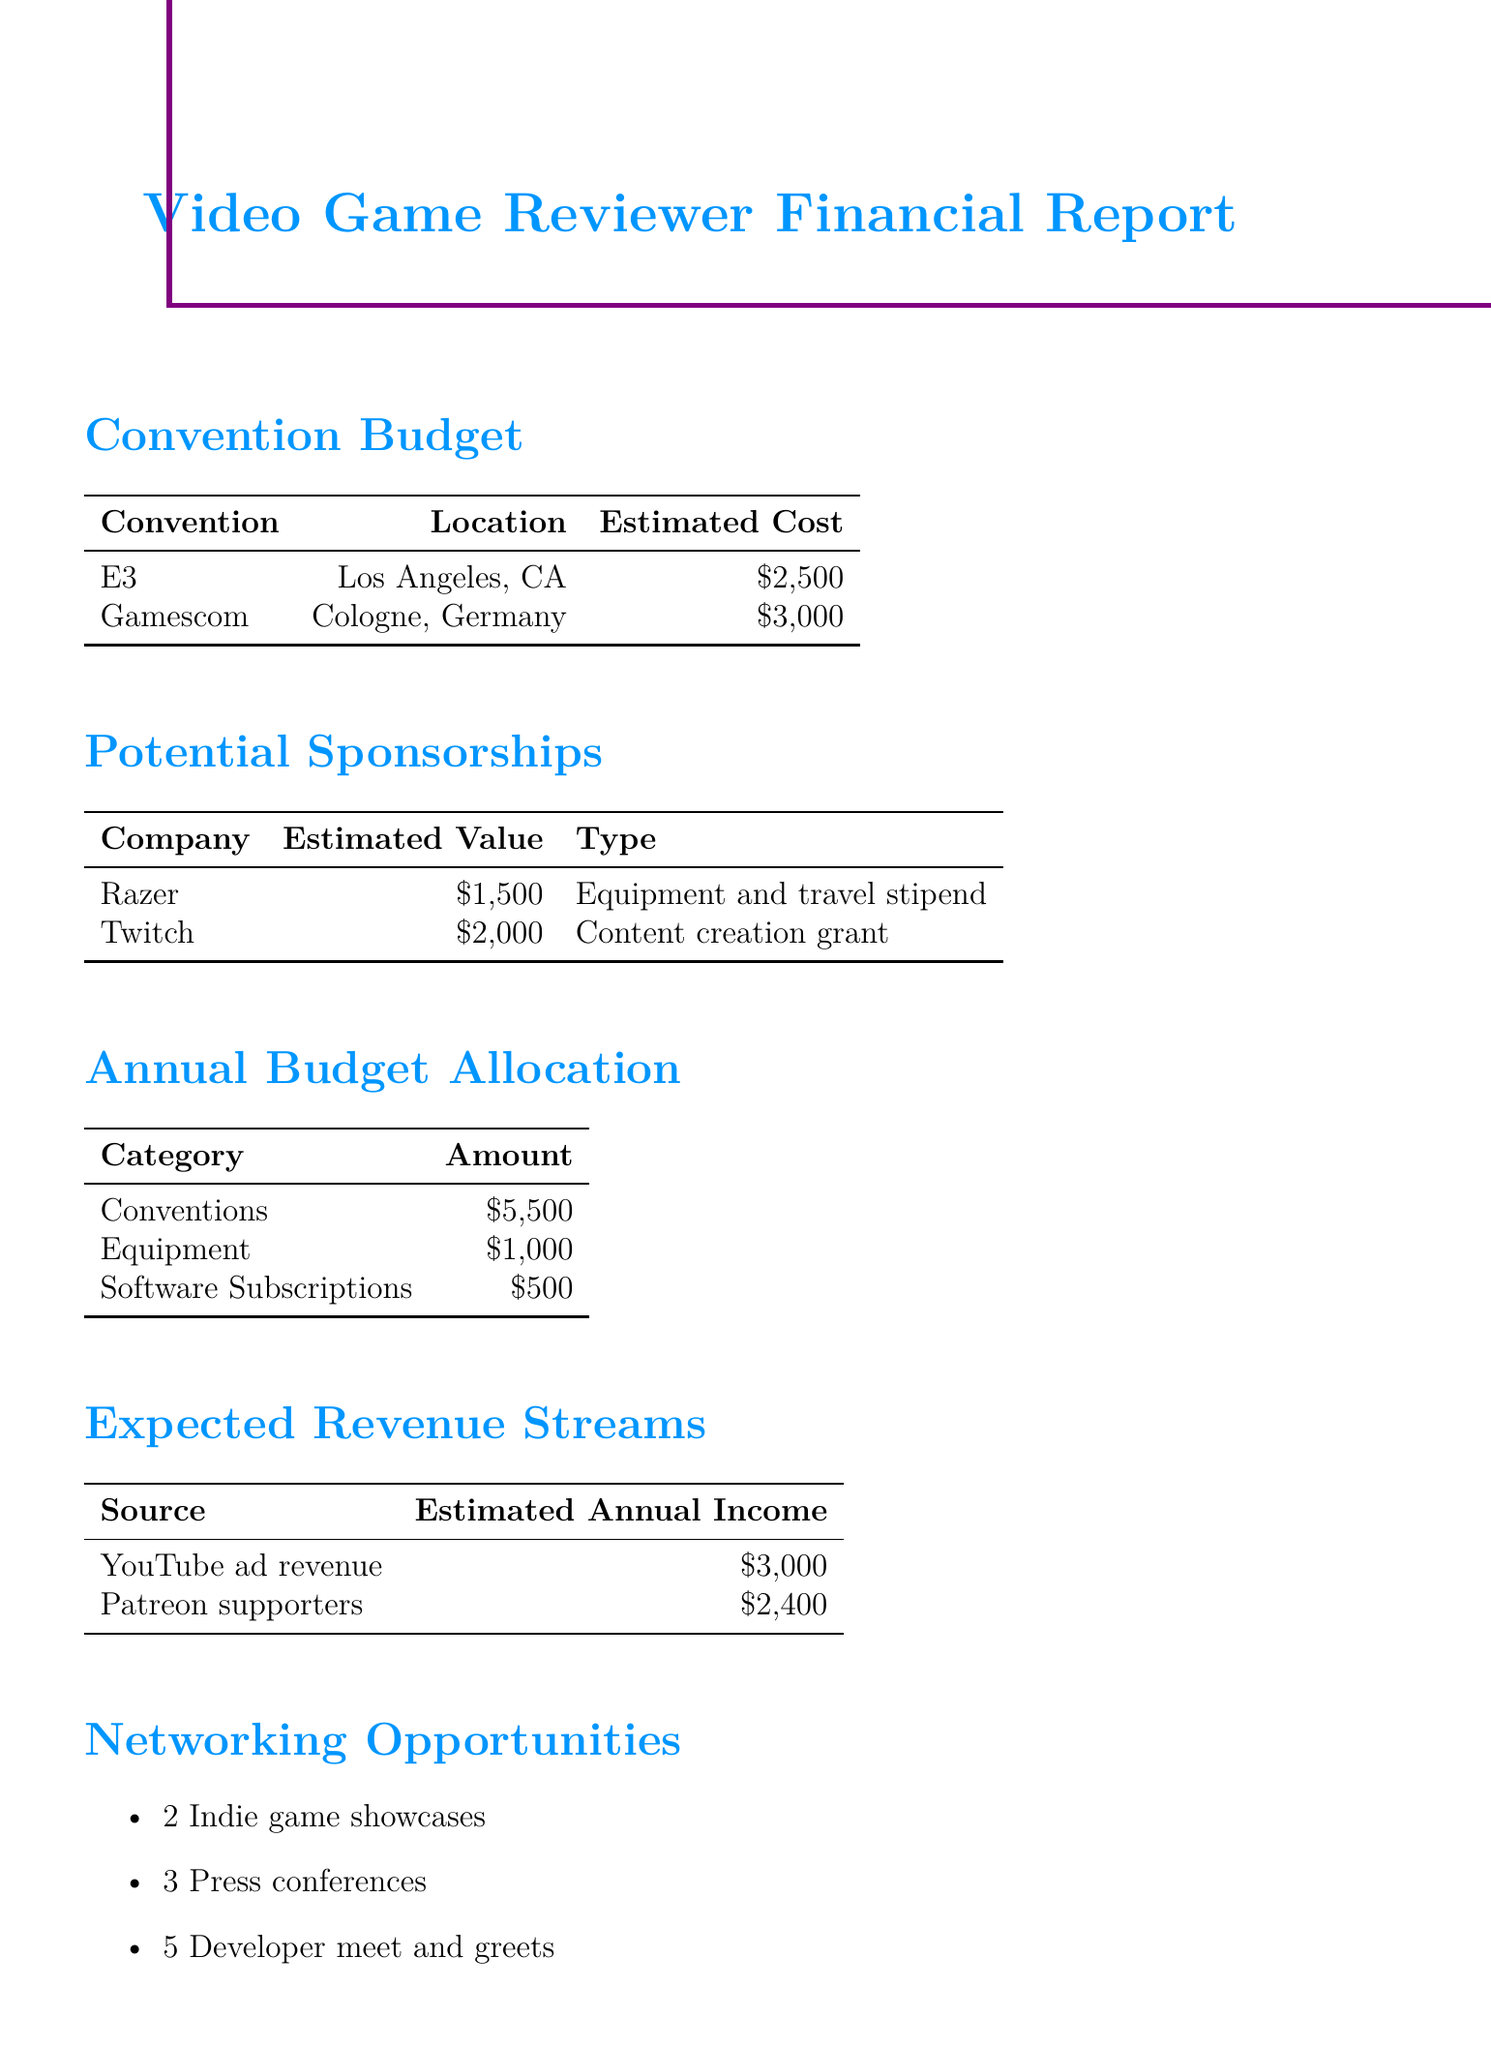What is the estimated cost for attending E3? The estimated cost for attending E3 is detailed in the conventions section of the report, which states it as $2500.
Answer: $2500 What is the total annual budget allocation for conventions? The total annual budget for conventions is mentioned in the annual budget allocation section, which is $5500.
Answer: $5500 What is the estimated value of the sponsorship from Twitch? The estimated value of the sponsorship from Twitch is shown in the potential sponsorships section, which is $2000.
Answer: $2000 How many developer meet and greets are expected? The expected number of developer meet and greets is listed in the networking opportunities section, which states 5.
Answer: 5 What is the total estimated annual income from YouTube ad revenue and Patreon supporters? The total estimated annual income is the sum of YouTube ad revenue ($3000) and Patreon supporters ($2400), which equals $5400.
Answer: $5400 What type of support does Razer provide as a potential sponsorship? The type of support provided by Razer is indicated as "Equipment and travel stipend" in the potential sponsorships section.
Answer: Equipment and travel stipend What is the estimated cost for attending Gamescom? The estimated cost for attending Gamescom is outlined in the conventions section as $3000.
Answer: $3000 How many indie game showcases are planned? The number of indie game showcases is mentioned under networking opportunities, which is 2.
Answer: 2 